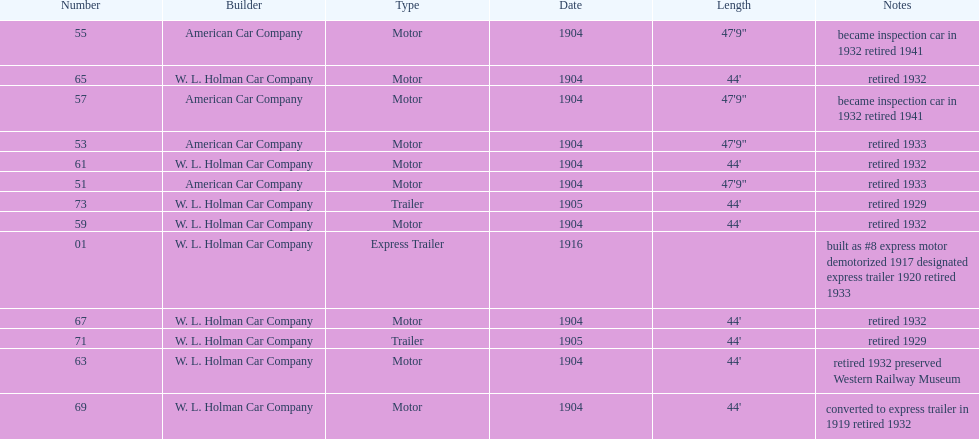In 1906, how many total rolling stock vehicles were in service? 12. Can you parse all the data within this table? {'header': ['Number', 'Builder', 'Type', 'Date', 'Length', 'Notes'], 'rows': [['55', 'American Car Company', 'Motor', '1904', '47\'9"', 'became inspection car in 1932 retired 1941'], ['65', 'W. L. Holman Car Company', 'Motor', '1904', "44'", 'retired 1932'], ['57', 'American Car Company', 'Motor', '1904', '47\'9"', 'became inspection car in 1932 retired 1941'], ['53', 'American Car Company', 'Motor', '1904', '47\'9"', 'retired 1933'], ['61', 'W. L. Holman Car Company', 'Motor', '1904', "44'", 'retired 1932'], ['51', 'American Car Company', 'Motor', '1904', '47\'9"', 'retired 1933'], ['73', 'W. L. Holman Car Company', 'Trailer', '1905', "44'", 'retired 1929'], ['59', 'W. L. Holman Car Company', 'Motor', '1904', "44'", 'retired 1932'], ['01', 'W. L. Holman Car Company', 'Express Trailer', '1916', '', 'built as #8 express motor demotorized 1917 designated express trailer 1920 retired 1933'], ['67', 'W. L. Holman Car Company', 'Motor', '1904', "44'", 'retired 1932'], ['71', 'W. L. Holman Car Company', 'Trailer', '1905', "44'", 'retired 1929'], ['63', 'W. L. Holman Car Company', 'Motor', '1904', "44'", 'retired 1932 preserved Western Railway Museum'], ['69', 'W. L. Holman Car Company', 'Motor', '1904', "44'", 'converted to express trailer in 1919 retired 1932']]} 